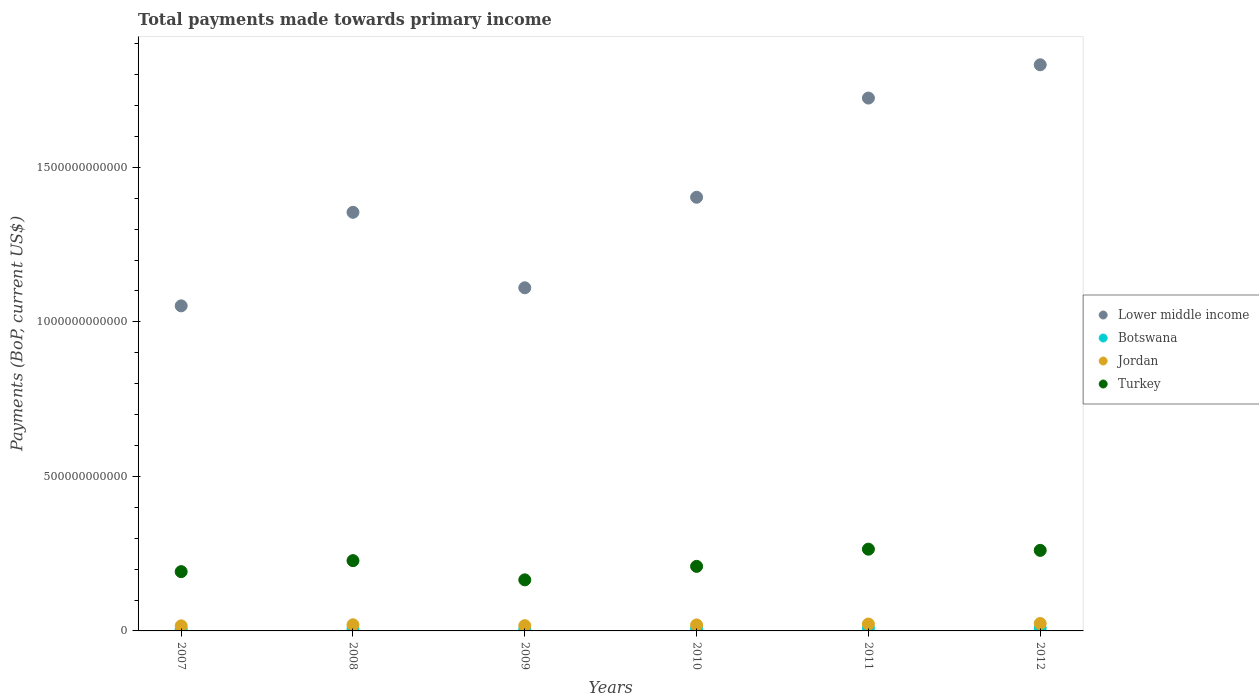How many different coloured dotlines are there?
Keep it short and to the point. 4. Is the number of dotlines equal to the number of legend labels?
Your answer should be compact. Yes. What is the total payments made towards primary income in Turkey in 2010?
Provide a succinct answer. 2.09e+11. Across all years, what is the maximum total payments made towards primary income in Turkey?
Your answer should be very brief. 2.64e+11. Across all years, what is the minimum total payments made towards primary income in Botswana?
Offer a terse response. 5.86e+09. In which year was the total payments made towards primary income in Botswana minimum?
Make the answer very short. 2009. What is the total total payments made towards primary income in Lower middle income in the graph?
Your response must be concise. 8.48e+12. What is the difference between the total payments made towards primary income in Botswana in 2009 and that in 2010?
Offer a very short reply. -1.30e+09. What is the difference between the total payments made towards primary income in Lower middle income in 2007 and the total payments made towards primary income in Jordan in 2010?
Keep it short and to the point. 1.03e+12. What is the average total payments made towards primary income in Lower middle income per year?
Keep it short and to the point. 1.41e+12. In the year 2012, what is the difference between the total payments made towards primary income in Turkey and total payments made towards primary income in Botswana?
Ensure brevity in your answer.  2.52e+11. What is the ratio of the total payments made towards primary income in Botswana in 2009 to that in 2012?
Give a very brief answer. 0.67. Is the total payments made towards primary income in Botswana in 2009 less than that in 2010?
Ensure brevity in your answer.  Yes. Is the difference between the total payments made towards primary income in Turkey in 2007 and 2011 greater than the difference between the total payments made towards primary income in Botswana in 2007 and 2011?
Your answer should be compact. No. What is the difference between the highest and the second highest total payments made towards primary income in Turkey?
Your answer should be very brief. 3.85e+09. What is the difference between the highest and the lowest total payments made towards primary income in Botswana?
Your answer should be very brief. 2.90e+09. Is it the case that in every year, the sum of the total payments made towards primary income in Botswana and total payments made towards primary income in Turkey  is greater than the sum of total payments made towards primary income in Lower middle income and total payments made towards primary income in Jordan?
Provide a succinct answer. Yes. Is it the case that in every year, the sum of the total payments made towards primary income in Turkey and total payments made towards primary income in Jordan  is greater than the total payments made towards primary income in Lower middle income?
Offer a very short reply. No. Does the total payments made towards primary income in Botswana monotonically increase over the years?
Provide a short and direct response. No. Is the total payments made towards primary income in Lower middle income strictly greater than the total payments made towards primary income in Jordan over the years?
Offer a terse response. Yes. How many dotlines are there?
Keep it short and to the point. 4. What is the difference between two consecutive major ticks on the Y-axis?
Offer a very short reply. 5.00e+11. Are the values on the major ticks of Y-axis written in scientific E-notation?
Offer a very short reply. No. Where does the legend appear in the graph?
Ensure brevity in your answer.  Center right. How many legend labels are there?
Give a very brief answer. 4. How are the legend labels stacked?
Provide a short and direct response. Vertical. What is the title of the graph?
Your answer should be compact. Total payments made towards primary income. What is the label or title of the Y-axis?
Offer a terse response. Payments (BoP, current US$). What is the Payments (BoP, current US$) in Lower middle income in 2007?
Give a very brief answer. 1.05e+12. What is the Payments (BoP, current US$) in Botswana in 2007?
Offer a terse response. 6.00e+09. What is the Payments (BoP, current US$) in Jordan in 2007?
Keep it short and to the point. 1.64e+1. What is the Payments (BoP, current US$) of Turkey in 2007?
Ensure brevity in your answer.  1.92e+11. What is the Payments (BoP, current US$) in Lower middle income in 2008?
Give a very brief answer. 1.35e+12. What is the Payments (BoP, current US$) of Botswana in 2008?
Give a very brief answer. 6.81e+09. What is the Payments (BoP, current US$) in Jordan in 2008?
Give a very brief answer. 1.99e+1. What is the Payments (BoP, current US$) of Turkey in 2008?
Provide a short and direct response. 2.27e+11. What is the Payments (BoP, current US$) in Lower middle income in 2009?
Ensure brevity in your answer.  1.11e+12. What is the Payments (BoP, current US$) of Botswana in 2009?
Your answer should be very brief. 5.86e+09. What is the Payments (BoP, current US$) in Jordan in 2009?
Provide a succinct answer. 1.70e+1. What is the Payments (BoP, current US$) in Turkey in 2009?
Offer a terse response. 1.65e+11. What is the Payments (BoP, current US$) in Lower middle income in 2010?
Make the answer very short. 1.40e+12. What is the Payments (BoP, current US$) of Botswana in 2010?
Ensure brevity in your answer.  7.16e+09. What is the Payments (BoP, current US$) in Jordan in 2010?
Your answer should be compact. 1.93e+1. What is the Payments (BoP, current US$) in Turkey in 2010?
Keep it short and to the point. 2.09e+11. What is the Payments (BoP, current US$) in Lower middle income in 2011?
Your answer should be compact. 1.72e+12. What is the Payments (BoP, current US$) in Botswana in 2011?
Your answer should be very brief. 8.39e+09. What is the Payments (BoP, current US$) of Jordan in 2011?
Ensure brevity in your answer.  2.23e+1. What is the Payments (BoP, current US$) of Turkey in 2011?
Offer a terse response. 2.64e+11. What is the Payments (BoP, current US$) in Lower middle income in 2012?
Your answer should be compact. 1.83e+12. What is the Payments (BoP, current US$) of Botswana in 2012?
Give a very brief answer. 8.76e+09. What is the Payments (BoP, current US$) of Jordan in 2012?
Ensure brevity in your answer.  2.41e+1. What is the Payments (BoP, current US$) of Turkey in 2012?
Make the answer very short. 2.61e+11. Across all years, what is the maximum Payments (BoP, current US$) in Lower middle income?
Your answer should be compact. 1.83e+12. Across all years, what is the maximum Payments (BoP, current US$) of Botswana?
Give a very brief answer. 8.76e+09. Across all years, what is the maximum Payments (BoP, current US$) of Jordan?
Give a very brief answer. 2.41e+1. Across all years, what is the maximum Payments (BoP, current US$) of Turkey?
Your answer should be very brief. 2.64e+11. Across all years, what is the minimum Payments (BoP, current US$) of Lower middle income?
Your answer should be compact. 1.05e+12. Across all years, what is the minimum Payments (BoP, current US$) of Botswana?
Give a very brief answer. 5.86e+09. Across all years, what is the minimum Payments (BoP, current US$) in Jordan?
Your answer should be compact. 1.64e+1. Across all years, what is the minimum Payments (BoP, current US$) in Turkey?
Provide a succinct answer. 1.65e+11. What is the total Payments (BoP, current US$) in Lower middle income in the graph?
Your answer should be very brief. 8.48e+12. What is the total Payments (BoP, current US$) in Botswana in the graph?
Offer a very short reply. 4.30e+1. What is the total Payments (BoP, current US$) in Jordan in the graph?
Your answer should be compact. 1.19e+11. What is the total Payments (BoP, current US$) in Turkey in the graph?
Offer a terse response. 1.32e+12. What is the difference between the Payments (BoP, current US$) in Lower middle income in 2007 and that in 2008?
Make the answer very short. -3.03e+11. What is the difference between the Payments (BoP, current US$) of Botswana in 2007 and that in 2008?
Offer a terse response. -8.14e+08. What is the difference between the Payments (BoP, current US$) in Jordan in 2007 and that in 2008?
Your answer should be compact. -3.45e+09. What is the difference between the Payments (BoP, current US$) in Turkey in 2007 and that in 2008?
Ensure brevity in your answer.  -3.56e+1. What is the difference between the Payments (BoP, current US$) of Lower middle income in 2007 and that in 2009?
Ensure brevity in your answer.  -5.85e+1. What is the difference between the Payments (BoP, current US$) of Botswana in 2007 and that in 2009?
Give a very brief answer. 1.35e+08. What is the difference between the Payments (BoP, current US$) of Jordan in 2007 and that in 2009?
Give a very brief answer. -6.23e+08. What is the difference between the Payments (BoP, current US$) of Turkey in 2007 and that in 2009?
Keep it short and to the point. 2.66e+1. What is the difference between the Payments (BoP, current US$) in Lower middle income in 2007 and that in 2010?
Ensure brevity in your answer.  -3.51e+11. What is the difference between the Payments (BoP, current US$) in Botswana in 2007 and that in 2010?
Provide a succinct answer. -1.17e+09. What is the difference between the Payments (BoP, current US$) of Jordan in 2007 and that in 2010?
Ensure brevity in your answer.  -2.92e+09. What is the difference between the Payments (BoP, current US$) of Turkey in 2007 and that in 2010?
Give a very brief answer. -1.71e+1. What is the difference between the Payments (BoP, current US$) of Lower middle income in 2007 and that in 2011?
Offer a very short reply. -6.72e+11. What is the difference between the Payments (BoP, current US$) of Botswana in 2007 and that in 2011?
Make the answer very short. -2.40e+09. What is the difference between the Payments (BoP, current US$) of Jordan in 2007 and that in 2011?
Ensure brevity in your answer.  -5.86e+09. What is the difference between the Payments (BoP, current US$) in Turkey in 2007 and that in 2011?
Provide a short and direct response. -7.27e+1. What is the difference between the Payments (BoP, current US$) of Lower middle income in 2007 and that in 2012?
Ensure brevity in your answer.  -7.80e+11. What is the difference between the Payments (BoP, current US$) in Botswana in 2007 and that in 2012?
Make the answer very short. -2.76e+09. What is the difference between the Payments (BoP, current US$) of Jordan in 2007 and that in 2012?
Provide a short and direct response. -7.63e+09. What is the difference between the Payments (BoP, current US$) in Turkey in 2007 and that in 2012?
Provide a short and direct response. -6.88e+1. What is the difference between the Payments (BoP, current US$) of Lower middle income in 2008 and that in 2009?
Make the answer very short. 2.44e+11. What is the difference between the Payments (BoP, current US$) in Botswana in 2008 and that in 2009?
Offer a very short reply. 9.49e+08. What is the difference between the Payments (BoP, current US$) in Jordan in 2008 and that in 2009?
Provide a short and direct response. 2.82e+09. What is the difference between the Payments (BoP, current US$) in Turkey in 2008 and that in 2009?
Your answer should be very brief. 6.22e+1. What is the difference between the Payments (BoP, current US$) of Lower middle income in 2008 and that in 2010?
Your response must be concise. -4.87e+1. What is the difference between the Payments (BoP, current US$) in Botswana in 2008 and that in 2010?
Provide a succinct answer. -3.52e+08. What is the difference between the Payments (BoP, current US$) in Jordan in 2008 and that in 2010?
Keep it short and to the point. 5.25e+08. What is the difference between the Payments (BoP, current US$) in Turkey in 2008 and that in 2010?
Keep it short and to the point. 1.85e+1. What is the difference between the Payments (BoP, current US$) of Lower middle income in 2008 and that in 2011?
Your answer should be compact. -3.70e+11. What is the difference between the Payments (BoP, current US$) of Botswana in 2008 and that in 2011?
Your answer should be compact. -1.58e+09. What is the difference between the Payments (BoP, current US$) in Jordan in 2008 and that in 2011?
Keep it short and to the point. -2.41e+09. What is the difference between the Payments (BoP, current US$) of Turkey in 2008 and that in 2011?
Provide a succinct answer. -3.71e+1. What is the difference between the Payments (BoP, current US$) of Lower middle income in 2008 and that in 2012?
Provide a succinct answer. -4.77e+11. What is the difference between the Payments (BoP, current US$) of Botswana in 2008 and that in 2012?
Provide a succinct answer. -1.95e+09. What is the difference between the Payments (BoP, current US$) of Jordan in 2008 and that in 2012?
Give a very brief answer. -4.18e+09. What is the difference between the Payments (BoP, current US$) of Turkey in 2008 and that in 2012?
Your answer should be very brief. -3.32e+1. What is the difference between the Payments (BoP, current US$) of Lower middle income in 2009 and that in 2010?
Make the answer very short. -2.93e+11. What is the difference between the Payments (BoP, current US$) of Botswana in 2009 and that in 2010?
Make the answer very short. -1.30e+09. What is the difference between the Payments (BoP, current US$) in Jordan in 2009 and that in 2010?
Your answer should be compact. -2.30e+09. What is the difference between the Payments (BoP, current US$) in Turkey in 2009 and that in 2010?
Keep it short and to the point. -4.36e+1. What is the difference between the Payments (BoP, current US$) in Lower middle income in 2009 and that in 2011?
Provide a succinct answer. -6.14e+11. What is the difference between the Payments (BoP, current US$) in Botswana in 2009 and that in 2011?
Offer a terse response. -2.53e+09. What is the difference between the Payments (BoP, current US$) of Jordan in 2009 and that in 2011?
Provide a succinct answer. -5.23e+09. What is the difference between the Payments (BoP, current US$) in Turkey in 2009 and that in 2011?
Provide a short and direct response. -9.93e+1. What is the difference between the Payments (BoP, current US$) of Lower middle income in 2009 and that in 2012?
Offer a terse response. -7.22e+11. What is the difference between the Payments (BoP, current US$) of Botswana in 2009 and that in 2012?
Keep it short and to the point. -2.90e+09. What is the difference between the Payments (BoP, current US$) in Jordan in 2009 and that in 2012?
Your answer should be compact. -7.01e+09. What is the difference between the Payments (BoP, current US$) of Turkey in 2009 and that in 2012?
Ensure brevity in your answer.  -9.54e+1. What is the difference between the Payments (BoP, current US$) in Lower middle income in 2010 and that in 2011?
Give a very brief answer. -3.21e+11. What is the difference between the Payments (BoP, current US$) of Botswana in 2010 and that in 2011?
Offer a terse response. -1.23e+09. What is the difference between the Payments (BoP, current US$) of Jordan in 2010 and that in 2011?
Provide a succinct answer. -2.93e+09. What is the difference between the Payments (BoP, current US$) in Turkey in 2010 and that in 2011?
Give a very brief answer. -5.56e+1. What is the difference between the Payments (BoP, current US$) of Lower middle income in 2010 and that in 2012?
Give a very brief answer. -4.29e+11. What is the difference between the Payments (BoP, current US$) in Botswana in 2010 and that in 2012?
Give a very brief answer. -1.60e+09. What is the difference between the Payments (BoP, current US$) in Jordan in 2010 and that in 2012?
Your response must be concise. -4.71e+09. What is the difference between the Payments (BoP, current US$) in Turkey in 2010 and that in 2012?
Your answer should be very brief. -5.18e+1. What is the difference between the Payments (BoP, current US$) of Lower middle income in 2011 and that in 2012?
Give a very brief answer. -1.08e+11. What is the difference between the Payments (BoP, current US$) of Botswana in 2011 and that in 2012?
Offer a terse response. -3.64e+08. What is the difference between the Payments (BoP, current US$) of Jordan in 2011 and that in 2012?
Provide a succinct answer. -1.78e+09. What is the difference between the Payments (BoP, current US$) of Turkey in 2011 and that in 2012?
Keep it short and to the point. 3.85e+09. What is the difference between the Payments (BoP, current US$) in Lower middle income in 2007 and the Payments (BoP, current US$) in Botswana in 2008?
Ensure brevity in your answer.  1.05e+12. What is the difference between the Payments (BoP, current US$) in Lower middle income in 2007 and the Payments (BoP, current US$) in Jordan in 2008?
Offer a terse response. 1.03e+12. What is the difference between the Payments (BoP, current US$) of Lower middle income in 2007 and the Payments (BoP, current US$) of Turkey in 2008?
Offer a terse response. 8.24e+11. What is the difference between the Payments (BoP, current US$) of Botswana in 2007 and the Payments (BoP, current US$) of Jordan in 2008?
Give a very brief answer. -1.39e+1. What is the difference between the Payments (BoP, current US$) in Botswana in 2007 and the Payments (BoP, current US$) in Turkey in 2008?
Give a very brief answer. -2.21e+11. What is the difference between the Payments (BoP, current US$) of Jordan in 2007 and the Payments (BoP, current US$) of Turkey in 2008?
Your answer should be very brief. -2.11e+11. What is the difference between the Payments (BoP, current US$) of Lower middle income in 2007 and the Payments (BoP, current US$) of Botswana in 2009?
Provide a succinct answer. 1.05e+12. What is the difference between the Payments (BoP, current US$) in Lower middle income in 2007 and the Payments (BoP, current US$) in Jordan in 2009?
Provide a short and direct response. 1.03e+12. What is the difference between the Payments (BoP, current US$) in Lower middle income in 2007 and the Payments (BoP, current US$) in Turkey in 2009?
Keep it short and to the point. 8.87e+11. What is the difference between the Payments (BoP, current US$) of Botswana in 2007 and the Payments (BoP, current US$) of Jordan in 2009?
Your answer should be very brief. -1.10e+1. What is the difference between the Payments (BoP, current US$) in Botswana in 2007 and the Payments (BoP, current US$) in Turkey in 2009?
Your answer should be compact. -1.59e+11. What is the difference between the Payments (BoP, current US$) in Jordan in 2007 and the Payments (BoP, current US$) in Turkey in 2009?
Give a very brief answer. -1.49e+11. What is the difference between the Payments (BoP, current US$) in Lower middle income in 2007 and the Payments (BoP, current US$) in Botswana in 2010?
Provide a short and direct response. 1.04e+12. What is the difference between the Payments (BoP, current US$) of Lower middle income in 2007 and the Payments (BoP, current US$) of Jordan in 2010?
Your response must be concise. 1.03e+12. What is the difference between the Payments (BoP, current US$) in Lower middle income in 2007 and the Payments (BoP, current US$) in Turkey in 2010?
Make the answer very short. 8.43e+11. What is the difference between the Payments (BoP, current US$) of Botswana in 2007 and the Payments (BoP, current US$) of Jordan in 2010?
Offer a very short reply. -1.33e+1. What is the difference between the Payments (BoP, current US$) in Botswana in 2007 and the Payments (BoP, current US$) in Turkey in 2010?
Provide a succinct answer. -2.03e+11. What is the difference between the Payments (BoP, current US$) of Jordan in 2007 and the Payments (BoP, current US$) of Turkey in 2010?
Offer a very short reply. -1.92e+11. What is the difference between the Payments (BoP, current US$) in Lower middle income in 2007 and the Payments (BoP, current US$) in Botswana in 2011?
Your response must be concise. 1.04e+12. What is the difference between the Payments (BoP, current US$) in Lower middle income in 2007 and the Payments (BoP, current US$) in Jordan in 2011?
Your answer should be compact. 1.03e+12. What is the difference between the Payments (BoP, current US$) in Lower middle income in 2007 and the Payments (BoP, current US$) in Turkey in 2011?
Make the answer very short. 7.87e+11. What is the difference between the Payments (BoP, current US$) in Botswana in 2007 and the Payments (BoP, current US$) in Jordan in 2011?
Ensure brevity in your answer.  -1.63e+1. What is the difference between the Payments (BoP, current US$) of Botswana in 2007 and the Payments (BoP, current US$) of Turkey in 2011?
Ensure brevity in your answer.  -2.59e+11. What is the difference between the Payments (BoP, current US$) of Jordan in 2007 and the Payments (BoP, current US$) of Turkey in 2011?
Your answer should be compact. -2.48e+11. What is the difference between the Payments (BoP, current US$) of Lower middle income in 2007 and the Payments (BoP, current US$) of Botswana in 2012?
Offer a very short reply. 1.04e+12. What is the difference between the Payments (BoP, current US$) of Lower middle income in 2007 and the Payments (BoP, current US$) of Jordan in 2012?
Give a very brief answer. 1.03e+12. What is the difference between the Payments (BoP, current US$) of Lower middle income in 2007 and the Payments (BoP, current US$) of Turkey in 2012?
Give a very brief answer. 7.91e+11. What is the difference between the Payments (BoP, current US$) of Botswana in 2007 and the Payments (BoP, current US$) of Jordan in 2012?
Offer a very short reply. -1.81e+1. What is the difference between the Payments (BoP, current US$) of Botswana in 2007 and the Payments (BoP, current US$) of Turkey in 2012?
Your answer should be compact. -2.55e+11. What is the difference between the Payments (BoP, current US$) of Jordan in 2007 and the Payments (BoP, current US$) of Turkey in 2012?
Keep it short and to the point. -2.44e+11. What is the difference between the Payments (BoP, current US$) in Lower middle income in 2008 and the Payments (BoP, current US$) in Botswana in 2009?
Keep it short and to the point. 1.35e+12. What is the difference between the Payments (BoP, current US$) in Lower middle income in 2008 and the Payments (BoP, current US$) in Jordan in 2009?
Your response must be concise. 1.34e+12. What is the difference between the Payments (BoP, current US$) of Lower middle income in 2008 and the Payments (BoP, current US$) of Turkey in 2009?
Offer a very short reply. 1.19e+12. What is the difference between the Payments (BoP, current US$) of Botswana in 2008 and the Payments (BoP, current US$) of Jordan in 2009?
Provide a short and direct response. -1.02e+1. What is the difference between the Payments (BoP, current US$) of Botswana in 2008 and the Payments (BoP, current US$) of Turkey in 2009?
Provide a short and direct response. -1.58e+11. What is the difference between the Payments (BoP, current US$) of Jordan in 2008 and the Payments (BoP, current US$) of Turkey in 2009?
Give a very brief answer. -1.45e+11. What is the difference between the Payments (BoP, current US$) of Lower middle income in 2008 and the Payments (BoP, current US$) of Botswana in 2010?
Your response must be concise. 1.35e+12. What is the difference between the Payments (BoP, current US$) in Lower middle income in 2008 and the Payments (BoP, current US$) in Jordan in 2010?
Your answer should be very brief. 1.34e+12. What is the difference between the Payments (BoP, current US$) in Lower middle income in 2008 and the Payments (BoP, current US$) in Turkey in 2010?
Provide a short and direct response. 1.15e+12. What is the difference between the Payments (BoP, current US$) of Botswana in 2008 and the Payments (BoP, current US$) of Jordan in 2010?
Ensure brevity in your answer.  -1.25e+1. What is the difference between the Payments (BoP, current US$) in Botswana in 2008 and the Payments (BoP, current US$) in Turkey in 2010?
Keep it short and to the point. -2.02e+11. What is the difference between the Payments (BoP, current US$) of Jordan in 2008 and the Payments (BoP, current US$) of Turkey in 2010?
Give a very brief answer. -1.89e+11. What is the difference between the Payments (BoP, current US$) of Lower middle income in 2008 and the Payments (BoP, current US$) of Botswana in 2011?
Ensure brevity in your answer.  1.35e+12. What is the difference between the Payments (BoP, current US$) of Lower middle income in 2008 and the Payments (BoP, current US$) of Jordan in 2011?
Ensure brevity in your answer.  1.33e+12. What is the difference between the Payments (BoP, current US$) in Lower middle income in 2008 and the Payments (BoP, current US$) in Turkey in 2011?
Ensure brevity in your answer.  1.09e+12. What is the difference between the Payments (BoP, current US$) of Botswana in 2008 and the Payments (BoP, current US$) of Jordan in 2011?
Give a very brief answer. -1.55e+1. What is the difference between the Payments (BoP, current US$) in Botswana in 2008 and the Payments (BoP, current US$) in Turkey in 2011?
Ensure brevity in your answer.  -2.58e+11. What is the difference between the Payments (BoP, current US$) in Jordan in 2008 and the Payments (BoP, current US$) in Turkey in 2011?
Provide a short and direct response. -2.45e+11. What is the difference between the Payments (BoP, current US$) of Lower middle income in 2008 and the Payments (BoP, current US$) of Botswana in 2012?
Your response must be concise. 1.35e+12. What is the difference between the Payments (BoP, current US$) in Lower middle income in 2008 and the Payments (BoP, current US$) in Jordan in 2012?
Offer a very short reply. 1.33e+12. What is the difference between the Payments (BoP, current US$) of Lower middle income in 2008 and the Payments (BoP, current US$) of Turkey in 2012?
Offer a terse response. 1.09e+12. What is the difference between the Payments (BoP, current US$) of Botswana in 2008 and the Payments (BoP, current US$) of Jordan in 2012?
Provide a succinct answer. -1.72e+1. What is the difference between the Payments (BoP, current US$) of Botswana in 2008 and the Payments (BoP, current US$) of Turkey in 2012?
Give a very brief answer. -2.54e+11. What is the difference between the Payments (BoP, current US$) in Jordan in 2008 and the Payments (BoP, current US$) in Turkey in 2012?
Offer a very short reply. -2.41e+11. What is the difference between the Payments (BoP, current US$) of Lower middle income in 2009 and the Payments (BoP, current US$) of Botswana in 2010?
Your answer should be compact. 1.10e+12. What is the difference between the Payments (BoP, current US$) in Lower middle income in 2009 and the Payments (BoP, current US$) in Jordan in 2010?
Offer a very short reply. 1.09e+12. What is the difference between the Payments (BoP, current US$) in Lower middle income in 2009 and the Payments (BoP, current US$) in Turkey in 2010?
Your answer should be very brief. 9.01e+11. What is the difference between the Payments (BoP, current US$) of Botswana in 2009 and the Payments (BoP, current US$) of Jordan in 2010?
Your response must be concise. -1.35e+1. What is the difference between the Payments (BoP, current US$) of Botswana in 2009 and the Payments (BoP, current US$) of Turkey in 2010?
Provide a short and direct response. -2.03e+11. What is the difference between the Payments (BoP, current US$) in Jordan in 2009 and the Payments (BoP, current US$) in Turkey in 2010?
Provide a succinct answer. -1.92e+11. What is the difference between the Payments (BoP, current US$) in Lower middle income in 2009 and the Payments (BoP, current US$) in Botswana in 2011?
Provide a succinct answer. 1.10e+12. What is the difference between the Payments (BoP, current US$) of Lower middle income in 2009 and the Payments (BoP, current US$) of Jordan in 2011?
Your answer should be very brief. 1.09e+12. What is the difference between the Payments (BoP, current US$) of Lower middle income in 2009 and the Payments (BoP, current US$) of Turkey in 2011?
Provide a short and direct response. 8.46e+11. What is the difference between the Payments (BoP, current US$) in Botswana in 2009 and the Payments (BoP, current US$) in Jordan in 2011?
Provide a succinct answer. -1.64e+1. What is the difference between the Payments (BoP, current US$) in Botswana in 2009 and the Payments (BoP, current US$) in Turkey in 2011?
Provide a short and direct response. -2.59e+11. What is the difference between the Payments (BoP, current US$) in Jordan in 2009 and the Payments (BoP, current US$) in Turkey in 2011?
Offer a very short reply. -2.47e+11. What is the difference between the Payments (BoP, current US$) in Lower middle income in 2009 and the Payments (BoP, current US$) in Botswana in 2012?
Provide a short and direct response. 1.10e+12. What is the difference between the Payments (BoP, current US$) of Lower middle income in 2009 and the Payments (BoP, current US$) of Jordan in 2012?
Your answer should be very brief. 1.09e+12. What is the difference between the Payments (BoP, current US$) of Lower middle income in 2009 and the Payments (BoP, current US$) of Turkey in 2012?
Give a very brief answer. 8.50e+11. What is the difference between the Payments (BoP, current US$) of Botswana in 2009 and the Payments (BoP, current US$) of Jordan in 2012?
Keep it short and to the point. -1.82e+1. What is the difference between the Payments (BoP, current US$) in Botswana in 2009 and the Payments (BoP, current US$) in Turkey in 2012?
Keep it short and to the point. -2.55e+11. What is the difference between the Payments (BoP, current US$) of Jordan in 2009 and the Payments (BoP, current US$) of Turkey in 2012?
Your answer should be very brief. -2.44e+11. What is the difference between the Payments (BoP, current US$) of Lower middle income in 2010 and the Payments (BoP, current US$) of Botswana in 2011?
Offer a very short reply. 1.39e+12. What is the difference between the Payments (BoP, current US$) of Lower middle income in 2010 and the Payments (BoP, current US$) of Jordan in 2011?
Provide a short and direct response. 1.38e+12. What is the difference between the Payments (BoP, current US$) in Lower middle income in 2010 and the Payments (BoP, current US$) in Turkey in 2011?
Keep it short and to the point. 1.14e+12. What is the difference between the Payments (BoP, current US$) in Botswana in 2010 and the Payments (BoP, current US$) in Jordan in 2011?
Your answer should be compact. -1.51e+1. What is the difference between the Payments (BoP, current US$) of Botswana in 2010 and the Payments (BoP, current US$) of Turkey in 2011?
Offer a terse response. -2.57e+11. What is the difference between the Payments (BoP, current US$) of Jordan in 2010 and the Payments (BoP, current US$) of Turkey in 2011?
Offer a very short reply. -2.45e+11. What is the difference between the Payments (BoP, current US$) of Lower middle income in 2010 and the Payments (BoP, current US$) of Botswana in 2012?
Your answer should be very brief. 1.39e+12. What is the difference between the Payments (BoP, current US$) in Lower middle income in 2010 and the Payments (BoP, current US$) in Jordan in 2012?
Provide a succinct answer. 1.38e+12. What is the difference between the Payments (BoP, current US$) in Lower middle income in 2010 and the Payments (BoP, current US$) in Turkey in 2012?
Offer a terse response. 1.14e+12. What is the difference between the Payments (BoP, current US$) in Botswana in 2010 and the Payments (BoP, current US$) in Jordan in 2012?
Your response must be concise. -1.69e+1. What is the difference between the Payments (BoP, current US$) in Botswana in 2010 and the Payments (BoP, current US$) in Turkey in 2012?
Give a very brief answer. -2.53e+11. What is the difference between the Payments (BoP, current US$) in Jordan in 2010 and the Payments (BoP, current US$) in Turkey in 2012?
Offer a very short reply. -2.41e+11. What is the difference between the Payments (BoP, current US$) in Lower middle income in 2011 and the Payments (BoP, current US$) in Botswana in 2012?
Offer a very short reply. 1.72e+12. What is the difference between the Payments (BoP, current US$) in Lower middle income in 2011 and the Payments (BoP, current US$) in Jordan in 2012?
Provide a succinct answer. 1.70e+12. What is the difference between the Payments (BoP, current US$) of Lower middle income in 2011 and the Payments (BoP, current US$) of Turkey in 2012?
Ensure brevity in your answer.  1.46e+12. What is the difference between the Payments (BoP, current US$) in Botswana in 2011 and the Payments (BoP, current US$) in Jordan in 2012?
Offer a terse response. -1.57e+1. What is the difference between the Payments (BoP, current US$) of Botswana in 2011 and the Payments (BoP, current US$) of Turkey in 2012?
Make the answer very short. -2.52e+11. What is the difference between the Payments (BoP, current US$) of Jordan in 2011 and the Payments (BoP, current US$) of Turkey in 2012?
Your answer should be very brief. -2.38e+11. What is the average Payments (BoP, current US$) of Lower middle income per year?
Offer a very short reply. 1.41e+12. What is the average Payments (BoP, current US$) in Botswana per year?
Keep it short and to the point. 7.16e+09. What is the average Payments (BoP, current US$) in Jordan per year?
Your answer should be very brief. 1.98e+1. What is the average Payments (BoP, current US$) in Turkey per year?
Ensure brevity in your answer.  2.20e+11. In the year 2007, what is the difference between the Payments (BoP, current US$) in Lower middle income and Payments (BoP, current US$) in Botswana?
Ensure brevity in your answer.  1.05e+12. In the year 2007, what is the difference between the Payments (BoP, current US$) of Lower middle income and Payments (BoP, current US$) of Jordan?
Give a very brief answer. 1.04e+12. In the year 2007, what is the difference between the Payments (BoP, current US$) of Lower middle income and Payments (BoP, current US$) of Turkey?
Offer a terse response. 8.60e+11. In the year 2007, what is the difference between the Payments (BoP, current US$) of Botswana and Payments (BoP, current US$) of Jordan?
Your answer should be compact. -1.04e+1. In the year 2007, what is the difference between the Payments (BoP, current US$) of Botswana and Payments (BoP, current US$) of Turkey?
Provide a succinct answer. -1.86e+11. In the year 2007, what is the difference between the Payments (BoP, current US$) of Jordan and Payments (BoP, current US$) of Turkey?
Your answer should be very brief. -1.75e+11. In the year 2008, what is the difference between the Payments (BoP, current US$) in Lower middle income and Payments (BoP, current US$) in Botswana?
Your answer should be very brief. 1.35e+12. In the year 2008, what is the difference between the Payments (BoP, current US$) of Lower middle income and Payments (BoP, current US$) of Jordan?
Make the answer very short. 1.33e+12. In the year 2008, what is the difference between the Payments (BoP, current US$) of Lower middle income and Payments (BoP, current US$) of Turkey?
Your answer should be compact. 1.13e+12. In the year 2008, what is the difference between the Payments (BoP, current US$) of Botswana and Payments (BoP, current US$) of Jordan?
Keep it short and to the point. -1.31e+1. In the year 2008, what is the difference between the Payments (BoP, current US$) of Botswana and Payments (BoP, current US$) of Turkey?
Offer a very short reply. -2.21e+11. In the year 2008, what is the difference between the Payments (BoP, current US$) in Jordan and Payments (BoP, current US$) in Turkey?
Your answer should be compact. -2.08e+11. In the year 2009, what is the difference between the Payments (BoP, current US$) of Lower middle income and Payments (BoP, current US$) of Botswana?
Your answer should be compact. 1.10e+12. In the year 2009, what is the difference between the Payments (BoP, current US$) in Lower middle income and Payments (BoP, current US$) in Jordan?
Keep it short and to the point. 1.09e+12. In the year 2009, what is the difference between the Payments (BoP, current US$) of Lower middle income and Payments (BoP, current US$) of Turkey?
Your response must be concise. 9.45e+11. In the year 2009, what is the difference between the Payments (BoP, current US$) of Botswana and Payments (BoP, current US$) of Jordan?
Offer a very short reply. -1.12e+1. In the year 2009, what is the difference between the Payments (BoP, current US$) of Botswana and Payments (BoP, current US$) of Turkey?
Your response must be concise. -1.59e+11. In the year 2009, what is the difference between the Payments (BoP, current US$) in Jordan and Payments (BoP, current US$) in Turkey?
Offer a terse response. -1.48e+11. In the year 2010, what is the difference between the Payments (BoP, current US$) of Lower middle income and Payments (BoP, current US$) of Botswana?
Provide a short and direct response. 1.40e+12. In the year 2010, what is the difference between the Payments (BoP, current US$) of Lower middle income and Payments (BoP, current US$) of Jordan?
Your answer should be compact. 1.38e+12. In the year 2010, what is the difference between the Payments (BoP, current US$) in Lower middle income and Payments (BoP, current US$) in Turkey?
Ensure brevity in your answer.  1.19e+12. In the year 2010, what is the difference between the Payments (BoP, current US$) in Botswana and Payments (BoP, current US$) in Jordan?
Provide a short and direct response. -1.22e+1. In the year 2010, what is the difference between the Payments (BoP, current US$) in Botswana and Payments (BoP, current US$) in Turkey?
Your answer should be compact. -2.02e+11. In the year 2010, what is the difference between the Payments (BoP, current US$) of Jordan and Payments (BoP, current US$) of Turkey?
Provide a short and direct response. -1.90e+11. In the year 2011, what is the difference between the Payments (BoP, current US$) in Lower middle income and Payments (BoP, current US$) in Botswana?
Ensure brevity in your answer.  1.72e+12. In the year 2011, what is the difference between the Payments (BoP, current US$) in Lower middle income and Payments (BoP, current US$) in Jordan?
Your answer should be compact. 1.70e+12. In the year 2011, what is the difference between the Payments (BoP, current US$) of Lower middle income and Payments (BoP, current US$) of Turkey?
Provide a short and direct response. 1.46e+12. In the year 2011, what is the difference between the Payments (BoP, current US$) in Botswana and Payments (BoP, current US$) in Jordan?
Give a very brief answer. -1.39e+1. In the year 2011, what is the difference between the Payments (BoP, current US$) in Botswana and Payments (BoP, current US$) in Turkey?
Keep it short and to the point. -2.56e+11. In the year 2011, what is the difference between the Payments (BoP, current US$) in Jordan and Payments (BoP, current US$) in Turkey?
Give a very brief answer. -2.42e+11. In the year 2012, what is the difference between the Payments (BoP, current US$) in Lower middle income and Payments (BoP, current US$) in Botswana?
Provide a succinct answer. 1.82e+12. In the year 2012, what is the difference between the Payments (BoP, current US$) of Lower middle income and Payments (BoP, current US$) of Jordan?
Your answer should be very brief. 1.81e+12. In the year 2012, what is the difference between the Payments (BoP, current US$) in Lower middle income and Payments (BoP, current US$) in Turkey?
Your response must be concise. 1.57e+12. In the year 2012, what is the difference between the Payments (BoP, current US$) of Botswana and Payments (BoP, current US$) of Jordan?
Your response must be concise. -1.53e+1. In the year 2012, what is the difference between the Payments (BoP, current US$) in Botswana and Payments (BoP, current US$) in Turkey?
Offer a very short reply. -2.52e+11. In the year 2012, what is the difference between the Payments (BoP, current US$) in Jordan and Payments (BoP, current US$) in Turkey?
Provide a short and direct response. -2.37e+11. What is the ratio of the Payments (BoP, current US$) of Lower middle income in 2007 to that in 2008?
Your answer should be compact. 0.78. What is the ratio of the Payments (BoP, current US$) in Botswana in 2007 to that in 2008?
Your answer should be compact. 0.88. What is the ratio of the Payments (BoP, current US$) of Jordan in 2007 to that in 2008?
Provide a succinct answer. 0.83. What is the ratio of the Payments (BoP, current US$) in Turkey in 2007 to that in 2008?
Provide a short and direct response. 0.84. What is the ratio of the Payments (BoP, current US$) in Lower middle income in 2007 to that in 2009?
Offer a very short reply. 0.95. What is the ratio of the Payments (BoP, current US$) of Jordan in 2007 to that in 2009?
Ensure brevity in your answer.  0.96. What is the ratio of the Payments (BoP, current US$) in Turkey in 2007 to that in 2009?
Give a very brief answer. 1.16. What is the ratio of the Payments (BoP, current US$) in Lower middle income in 2007 to that in 2010?
Your answer should be compact. 0.75. What is the ratio of the Payments (BoP, current US$) of Botswana in 2007 to that in 2010?
Your answer should be compact. 0.84. What is the ratio of the Payments (BoP, current US$) of Jordan in 2007 to that in 2010?
Keep it short and to the point. 0.85. What is the ratio of the Payments (BoP, current US$) in Turkey in 2007 to that in 2010?
Give a very brief answer. 0.92. What is the ratio of the Payments (BoP, current US$) of Lower middle income in 2007 to that in 2011?
Offer a terse response. 0.61. What is the ratio of the Payments (BoP, current US$) in Botswana in 2007 to that in 2011?
Make the answer very short. 0.71. What is the ratio of the Payments (BoP, current US$) of Jordan in 2007 to that in 2011?
Keep it short and to the point. 0.74. What is the ratio of the Payments (BoP, current US$) in Turkey in 2007 to that in 2011?
Give a very brief answer. 0.73. What is the ratio of the Payments (BoP, current US$) in Lower middle income in 2007 to that in 2012?
Provide a succinct answer. 0.57. What is the ratio of the Payments (BoP, current US$) in Botswana in 2007 to that in 2012?
Provide a short and direct response. 0.68. What is the ratio of the Payments (BoP, current US$) of Jordan in 2007 to that in 2012?
Give a very brief answer. 0.68. What is the ratio of the Payments (BoP, current US$) in Turkey in 2007 to that in 2012?
Make the answer very short. 0.74. What is the ratio of the Payments (BoP, current US$) of Lower middle income in 2008 to that in 2009?
Keep it short and to the point. 1.22. What is the ratio of the Payments (BoP, current US$) of Botswana in 2008 to that in 2009?
Provide a short and direct response. 1.16. What is the ratio of the Payments (BoP, current US$) in Jordan in 2008 to that in 2009?
Your response must be concise. 1.17. What is the ratio of the Payments (BoP, current US$) in Turkey in 2008 to that in 2009?
Your answer should be compact. 1.38. What is the ratio of the Payments (BoP, current US$) in Lower middle income in 2008 to that in 2010?
Provide a succinct answer. 0.97. What is the ratio of the Payments (BoP, current US$) in Botswana in 2008 to that in 2010?
Keep it short and to the point. 0.95. What is the ratio of the Payments (BoP, current US$) in Jordan in 2008 to that in 2010?
Your response must be concise. 1.03. What is the ratio of the Payments (BoP, current US$) of Turkey in 2008 to that in 2010?
Keep it short and to the point. 1.09. What is the ratio of the Payments (BoP, current US$) in Lower middle income in 2008 to that in 2011?
Provide a short and direct response. 0.79. What is the ratio of the Payments (BoP, current US$) in Botswana in 2008 to that in 2011?
Your response must be concise. 0.81. What is the ratio of the Payments (BoP, current US$) of Jordan in 2008 to that in 2011?
Make the answer very short. 0.89. What is the ratio of the Payments (BoP, current US$) in Turkey in 2008 to that in 2011?
Your answer should be very brief. 0.86. What is the ratio of the Payments (BoP, current US$) in Lower middle income in 2008 to that in 2012?
Provide a short and direct response. 0.74. What is the ratio of the Payments (BoP, current US$) in Botswana in 2008 to that in 2012?
Your response must be concise. 0.78. What is the ratio of the Payments (BoP, current US$) in Jordan in 2008 to that in 2012?
Your answer should be compact. 0.83. What is the ratio of the Payments (BoP, current US$) of Turkey in 2008 to that in 2012?
Your response must be concise. 0.87. What is the ratio of the Payments (BoP, current US$) of Lower middle income in 2009 to that in 2010?
Offer a very short reply. 0.79. What is the ratio of the Payments (BoP, current US$) of Botswana in 2009 to that in 2010?
Keep it short and to the point. 0.82. What is the ratio of the Payments (BoP, current US$) in Jordan in 2009 to that in 2010?
Provide a succinct answer. 0.88. What is the ratio of the Payments (BoP, current US$) of Turkey in 2009 to that in 2010?
Your answer should be very brief. 0.79. What is the ratio of the Payments (BoP, current US$) in Lower middle income in 2009 to that in 2011?
Offer a terse response. 0.64. What is the ratio of the Payments (BoP, current US$) in Botswana in 2009 to that in 2011?
Make the answer very short. 0.7. What is the ratio of the Payments (BoP, current US$) of Jordan in 2009 to that in 2011?
Offer a terse response. 0.77. What is the ratio of the Payments (BoP, current US$) in Turkey in 2009 to that in 2011?
Make the answer very short. 0.62. What is the ratio of the Payments (BoP, current US$) of Lower middle income in 2009 to that in 2012?
Offer a very short reply. 0.61. What is the ratio of the Payments (BoP, current US$) of Botswana in 2009 to that in 2012?
Your answer should be compact. 0.67. What is the ratio of the Payments (BoP, current US$) in Jordan in 2009 to that in 2012?
Your response must be concise. 0.71. What is the ratio of the Payments (BoP, current US$) of Turkey in 2009 to that in 2012?
Keep it short and to the point. 0.63. What is the ratio of the Payments (BoP, current US$) of Lower middle income in 2010 to that in 2011?
Make the answer very short. 0.81. What is the ratio of the Payments (BoP, current US$) of Botswana in 2010 to that in 2011?
Your answer should be compact. 0.85. What is the ratio of the Payments (BoP, current US$) in Jordan in 2010 to that in 2011?
Your response must be concise. 0.87. What is the ratio of the Payments (BoP, current US$) in Turkey in 2010 to that in 2011?
Give a very brief answer. 0.79. What is the ratio of the Payments (BoP, current US$) in Lower middle income in 2010 to that in 2012?
Your answer should be very brief. 0.77. What is the ratio of the Payments (BoP, current US$) in Botswana in 2010 to that in 2012?
Give a very brief answer. 0.82. What is the ratio of the Payments (BoP, current US$) in Jordan in 2010 to that in 2012?
Offer a terse response. 0.8. What is the ratio of the Payments (BoP, current US$) of Turkey in 2010 to that in 2012?
Your answer should be very brief. 0.8. What is the ratio of the Payments (BoP, current US$) of Botswana in 2011 to that in 2012?
Make the answer very short. 0.96. What is the ratio of the Payments (BoP, current US$) of Jordan in 2011 to that in 2012?
Your answer should be compact. 0.93. What is the ratio of the Payments (BoP, current US$) of Turkey in 2011 to that in 2012?
Ensure brevity in your answer.  1.01. What is the difference between the highest and the second highest Payments (BoP, current US$) in Lower middle income?
Your answer should be very brief. 1.08e+11. What is the difference between the highest and the second highest Payments (BoP, current US$) in Botswana?
Offer a very short reply. 3.64e+08. What is the difference between the highest and the second highest Payments (BoP, current US$) of Jordan?
Give a very brief answer. 1.78e+09. What is the difference between the highest and the second highest Payments (BoP, current US$) in Turkey?
Provide a short and direct response. 3.85e+09. What is the difference between the highest and the lowest Payments (BoP, current US$) of Lower middle income?
Make the answer very short. 7.80e+11. What is the difference between the highest and the lowest Payments (BoP, current US$) of Botswana?
Your answer should be very brief. 2.90e+09. What is the difference between the highest and the lowest Payments (BoP, current US$) of Jordan?
Provide a succinct answer. 7.63e+09. What is the difference between the highest and the lowest Payments (BoP, current US$) of Turkey?
Provide a succinct answer. 9.93e+1. 